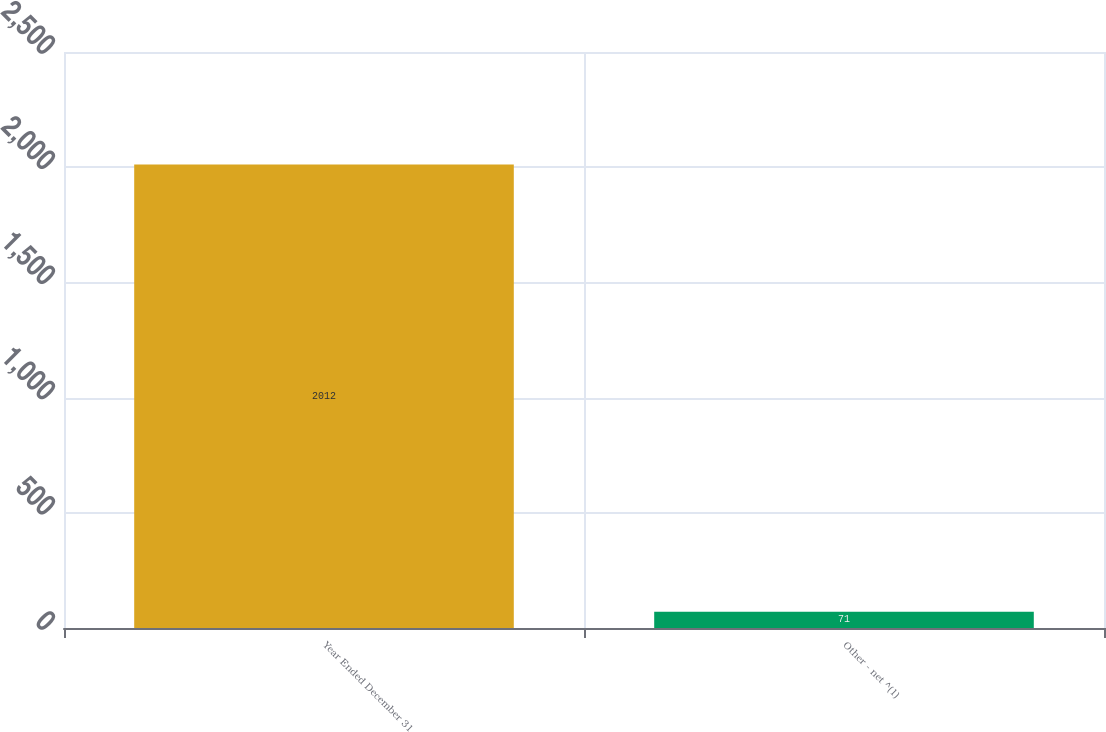Convert chart. <chart><loc_0><loc_0><loc_500><loc_500><bar_chart><fcel>Year Ended December 31<fcel>Other - net ^(1)<nl><fcel>2012<fcel>71<nl></chart> 